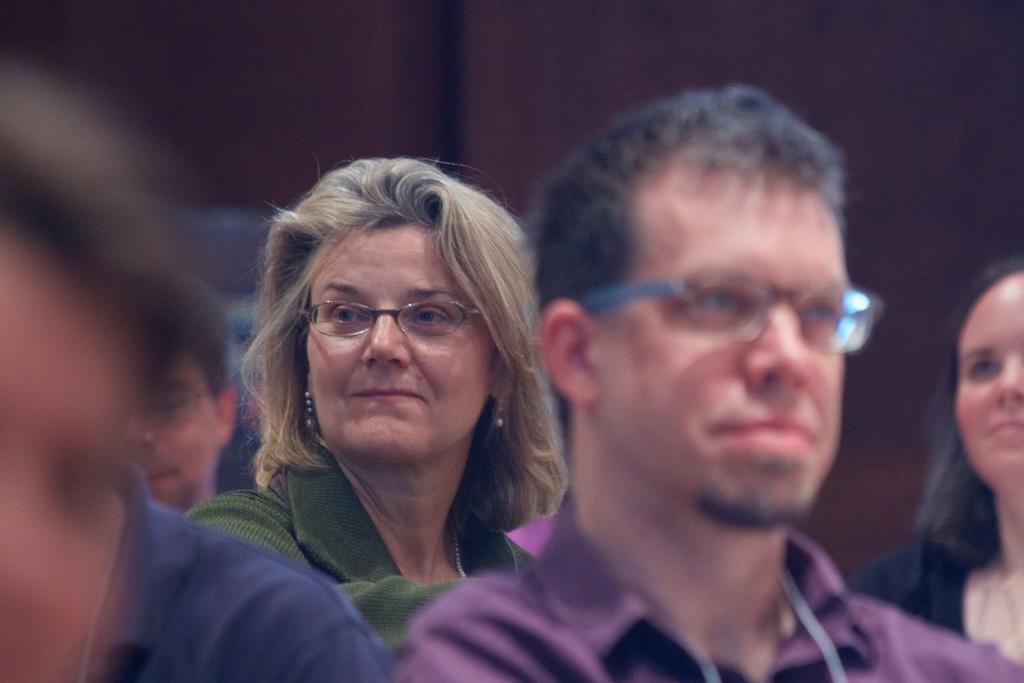Who or what can be seen in the image? There are people in the image. Can you describe any specific details about the people? Some of the people in the image are wearing spectacles. What is the title of the book held by the person in the image? There is no book visible in the image, so it is not possible to determine the title. 